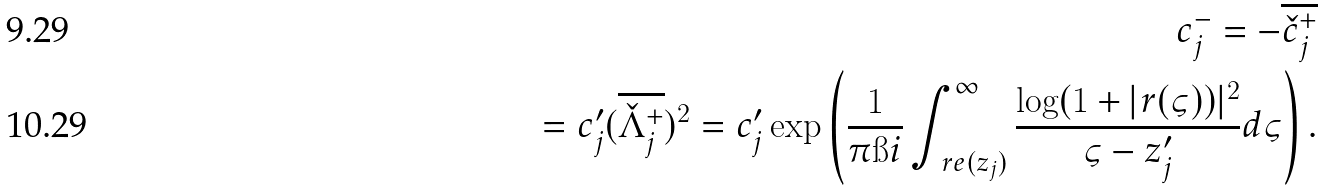<formula> <loc_0><loc_0><loc_500><loc_500>c ^ { - } _ { j } = - \overline { \check { c } ^ { + } _ { j } } \\ = c _ { j } ^ { \prime } ( \overline { \check { \Lambda } _ { j } ^ { + } } ) ^ { 2 } = c _ { j } ^ { \prime } \exp \left ( \frac { 1 } { \pi \i i } \int _ { \ r e ( z _ { j } ) } ^ { \infty } \frac { \log ( 1 + | r ( \varsigma ) ) | ^ { 2 } } { \varsigma - z _ { j } ^ { \prime } } d \varsigma \right ) .</formula> 